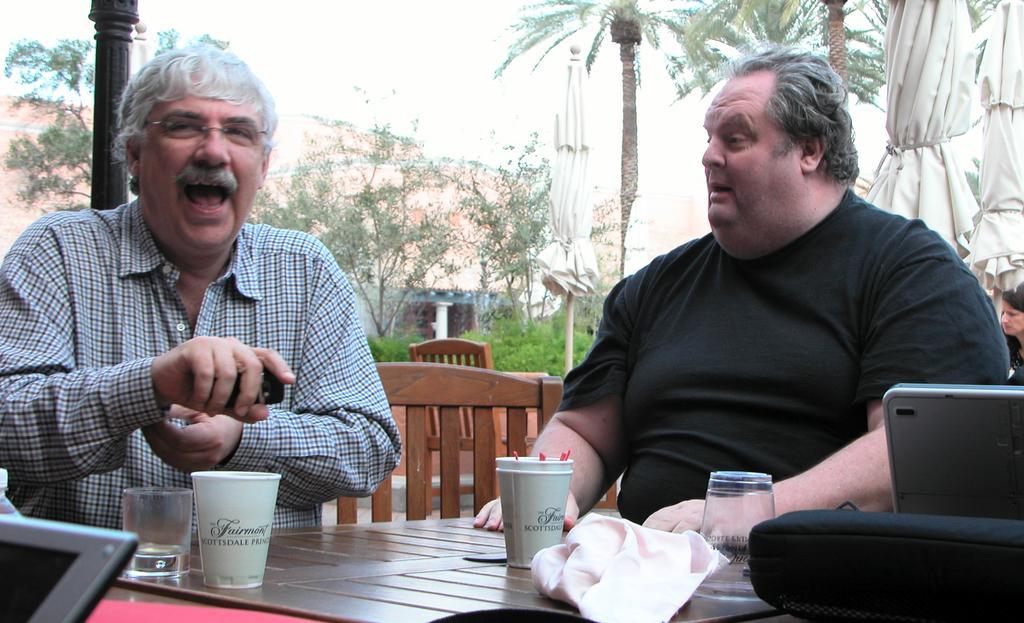How would you summarize this image in a sentence or two? This image is clicked outside. There are trees on the top and there are tables in the bottom. On the table there are glasses, cups, laptops, napkins. There are chairs near the tables. Two people are sitting on chairs, one is on the right side other one is on the left side. 